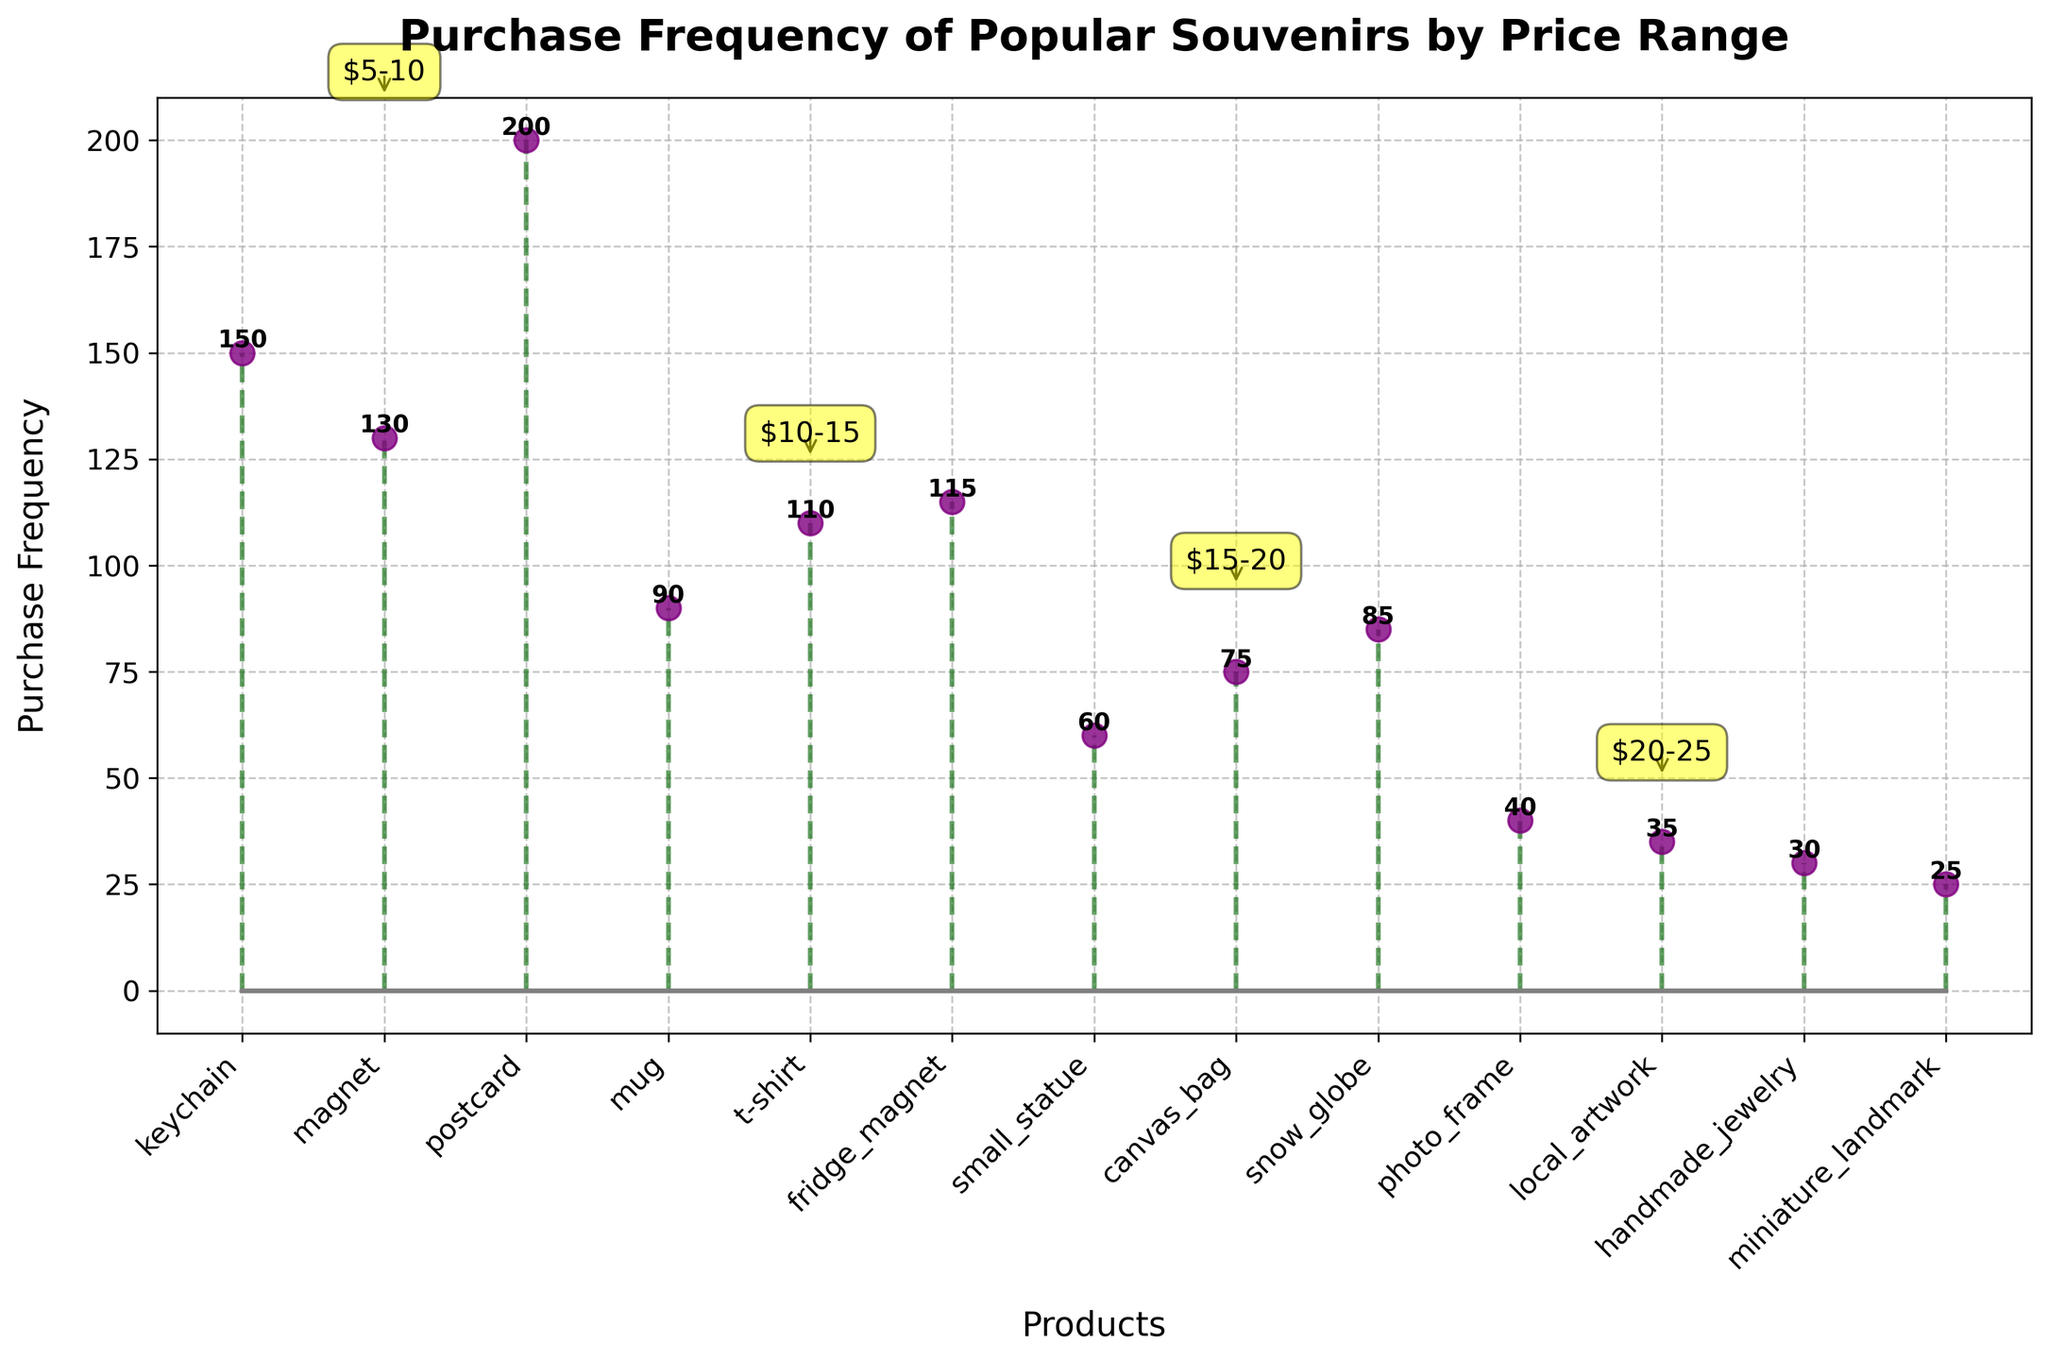what is the title of the plot? The title of the plot is displayed at the top and reads, "Purchase Frequency of Popular Souvenirs by Price Range."
Answer: Purchase Frequency of Popular Souvenirs by Price Range how many different price ranges are there in the plot? The plot divides the products into distinct price ranges, which are annotated. There are 5 unique price ranges labeled from $5-10 to $25-30.
Answer: 5 which product has the highest purchase frequency? To determine the product with the highest purchase frequency, look for the tallest stem. "Postcard" has a frequency of 200, which is the highest in the plot.
Answer: postcard what is the purchase frequency of magnets? The stem plot shows two types of magnets: "Magnet" at $5-10 with a frequency of 130 and "Fridge Magnet" at $10-15 with a frequency of 115.
Answer: 130 (for type 'Magnet') how does the purchase frequency of t-shirts compare with mugs? Observing the height of the stems, "T-shirt" under $10-15 has a frequency of 110, and "Mug" under the same price range has a frequency of 90. Thus, T-shirts are bought more frequently than mugs.
Answer: T-shirts are higher what is the average purchase frequency of products in the $15-20 range? The products in the $15-20 range are "Small Statue" (60), "Canvas Bag" (75), and "Snow Globe" (85). Calculate the average: (60+75+85) / 3 = 73.33.
Answer: 73.33 which price range has the lowest total purchase frequency? Sum the frequencies for each price range and compare. The $25-30 range has "Handmade Jewelry" (30) and "Miniature Landmark" (25), summing to 55, which is the lowest total.
Answer: $25-30 what is the difference in purchase frequency between the highest and lowest product in the plot? The highest frequency is "Postcard" with 200 and the lowest is "Miniature Landmark" with 25. The difference is 200 - 25 = 175.
Answer: 175 how many products have a purchase frequency greater than 100? Count the stems whose height is above 100. "Keychain" (150), "Magnet" (130), "Postcard" (200), "T-shirt" (110), and "Fridge Magnet" (115) are such products.
Answer: 5 are there more products with a purchase frequency under 50 or over 100? Count the products with purchase frequency under 50 and those over 100. Under 50: {Photo Frame (40), Local Artwork (35), Handmade Jewelry (30), Miniature Landmark (25)} = 4. Over 100: {Keychain (150), Magnet (130), Postcard (200), T-shirt (110), Fridge Magnet (115)} = 5. More products over 100.
Answer: More over 100 